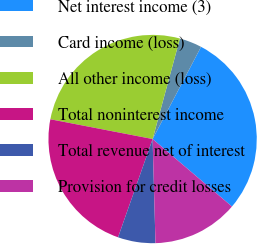Convert chart to OTSL. <chart><loc_0><loc_0><loc_500><loc_500><pie_chart><fcel>Net interest income (3)<fcel>Card income (loss)<fcel>All other income (loss)<fcel>Total noninterest income<fcel>Total revenue net of interest<fcel>Provision for credit losses<nl><fcel>28.52%<fcel>3.48%<fcel>26.18%<fcel>22.66%<fcel>5.82%<fcel>13.34%<nl></chart> 